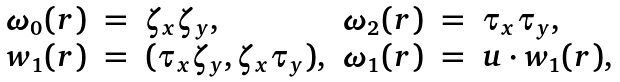<formula> <loc_0><loc_0><loc_500><loc_500>\begin{array} { r c l r c l } \omega _ { 0 } ( { r } ) & = & \zeta _ { x } \zeta _ { y } , & \omega _ { 2 } ( { r } ) & = & \tau _ { x } \tau _ { y } , \\ { w } _ { 1 } ( { r } ) & = & ( \tau _ { x } \zeta _ { y } , \zeta _ { x } \tau _ { y } ) , & \omega _ { 1 } ( { r } ) & = & { u } \cdot { w } _ { 1 } ( { r } ) , \end{array}</formula> 